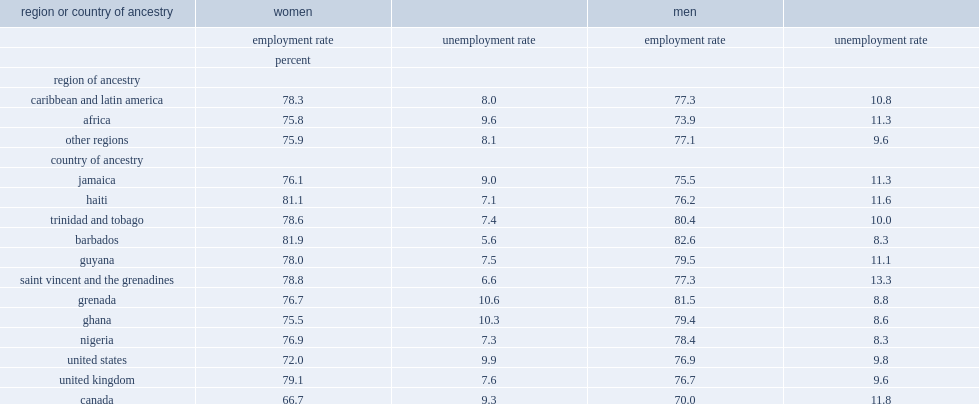Which region of ancestry has a higher uunemployment? women whose region of ancestry was africa or those in caribbean and latin america? Women. 